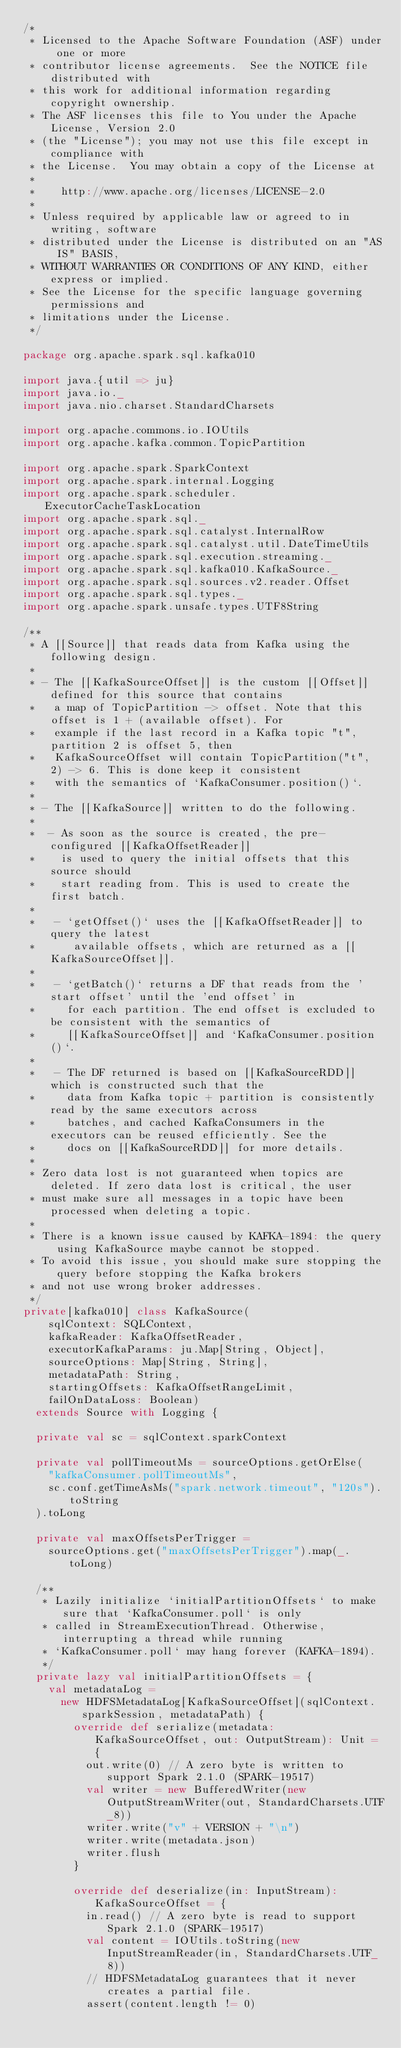Convert code to text. <code><loc_0><loc_0><loc_500><loc_500><_Scala_>/*
 * Licensed to the Apache Software Foundation (ASF) under one or more
 * contributor license agreements.  See the NOTICE file distributed with
 * this work for additional information regarding copyright ownership.
 * The ASF licenses this file to You under the Apache License, Version 2.0
 * (the "License"); you may not use this file except in compliance with
 * the License.  You may obtain a copy of the License at
 *
 *    http://www.apache.org/licenses/LICENSE-2.0
 *
 * Unless required by applicable law or agreed to in writing, software
 * distributed under the License is distributed on an "AS IS" BASIS,
 * WITHOUT WARRANTIES OR CONDITIONS OF ANY KIND, either express or implied.
 * See the License for the specific language governing permissions and
 * limitations under the License.
 */

package org.apache.spark.sql.kafka010

import java.{util => ju}
import java.io._
import java.nio.charset.StandardCharsets

import org.apache.commons.io.IOUtils
import org.apache.kafka.common.TopicPartition

import org.apache.spark.SparkContext
import org.apache.spark.internal.Logging
import org.apache.spark.scheduler.ExecutorCacheTaskLocation
import org.apache.spark.sql._
import org.apache.spark.sql.catalyst.InternalRow
import org.apache.spark.sql.catalyst.util.DateTimeUtils
import org.apache.spark.sql.execution.streaming._
import org.apache.spark.sql.kafka010.KafkaSource._
import org.apache.spark.sql.sources.v2.reader.Offset
import org.apache.spark.sql.types._
import org.apache.spark.unsafe.types.UTF8String

/**
 * A [[Source]] that reads data from Kafka using the following design.
 *
 * - The [[KafkaSourceOffset]] is the custom [[Offset]] defined for this source that contains
 *   a map of TopicPartition -> offset. Note that this offset is 1 + (available offset). For
 *   example if the last record in a Kafka topic "t", partition 2 is offset 5, then
 *   KafkaSourceOffset will contain TopicPartition("t", 2) -> 6. This is done keep it consistent
 *   with the semantics of `KafkaConsumer.position()`.
 *
 * - The [[KafkaSource]] written to do the following.
 *
 *  - As soon as the source is created, the pre-configured [[KafkaOffsetReader]]
 *    is used to query the initial offsets that this source should
 *    start reading from. This is used to create the first batch.
 *
 *   - `getOffset()` uses the [[KafkaOffsetReader]] to query the latest
 *      available offsets, which are returned as a [[KafkaSourceOffset]].
 *
 *   - `getBatch()` returns a DF that reads from the 'start offset' until the 'end offset' in
 *     for each partition. The end offset is excluded to be consistent with the semantics of
 *     [[KafkaSourceOffset]] and `KafkaConsumer.position()`.
 *
 *   - The DF returned is based on [[KafkaSourceRDD]] which is constructed such that the
 *     data from Kafka topic + partition is consistently read by the same executors across
 *     batches, and cached KafkaConsumers in the executors can be reused efficiently. See the
 *     docs on [[KafkaSourceRDD]] for more details.
 *
 * Zero data lost is not guaranteed when topics are deleted. If zero data lost is critical, the user
 * must make sure all messages in a topic have been processed when deleting a topic.
 *
 * There is a known issue caused by KAFKA-1894: the query using KafkaSource maybe cannot be stopped.
 * To avoid this issue, you should make sure stopping the query before stopping the Kafka brokers
 * and not use wrong broker addresses.
 */
private[kafka010] class KafkaSource(
    sqlContext: SQLContext,
    kafkaReader: KafkaOffsetReader,
    executorKafkaParams: ju.Map[String, Object],
    sourceOptions: Map[String, String],
    metadataPath: String,
    startingOffsets: KafkaOffsetRangeLimit,
    failOnDataLoss: Boolean)
  extends Source with Logging {

  private val sc = sqlContext.sparkContext

  private val pollTimeoutMs = sourceOptions.getOrElse(
    "kafkaConsumer.pollTimeoutMs",
    sc.conf.getTimeAsMs("spark.network.timeout", "120s").toString
  ).toLong

  private val maxOffsetsPerTrigger =
    sourceOptions.get("maxOffsetsPerTrigger").map(_.toLong)

  /**
   * Lazily initialize `initialPartitionOffsets` to make sure that `KafkaConsumer.poll` is only
   * called in StreamExecutionThread. Otherwise, interrupting a thread while running
   * `KafkaConsumer.poll` may hang forever (KAFKA-1894).
   */
  private lazy val initialPartitionOffsets = {
    val metadataLog =
      new HDFSMetadataLog[KafkaSourceOffset](sqlContext.sparkSession, metadataPath) {
        override def serialize(metadata: KafkaSourceOffset, out: OutputStream): Unit = {
          out.write(0) // A zero byte is written to support Spark 2.1.0 (SPARK-19517)
          val writer = new BufferedWriter(new OutputStreamWriter(out, StandardCharsets.UTF_8))
          writer.write("v" + VERSION + "\n")
          writer.write(metadata.json)
          writer.flush
        }

        override def deserialize(in: InputStream): KafkaSourceOffset = {
          in.read() // A zero byte is read to support Spark 2.1.0 (SPARK-19517)
          val content = IOUtils.toString(new InputStreamReader(in, StandardCharsets.UTF_8))
          // HDFSMetadataLog guarantees that it never creates a partial file.
          assert(content.length != 0)</code> 